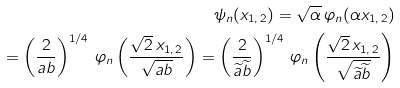<formula> <loc_0><loc_0><loc_500><loc_500>\psi _ { n } ( x _ { 1 , \, 2 } ) = \sqrt { \alpha } \, \varphi _ { n } ( \alpha x _ { 1 , \, 2 } ) \\ = \left ( \frac { 2 } { a b } \right ) ^ { 1 / 4 } \, \varphi _ { n } \left ( \frac { \sqrt { 2 } \, x _ { 1 , \, 2 } } { \sqrt { a b } } \right ) = \left ( \frac { 2 } { { \widetilde { a } } { \widetilde { b } } } \right ) ^ { 1 / 4 } \, \varphi _ { n } \left ( \frac { \sqrt { 2 } \, x _ { 1 , \, 2 } } { \sqrt { { \widetilde { a } } { \widetilde { b } } } } \right )</formula> 